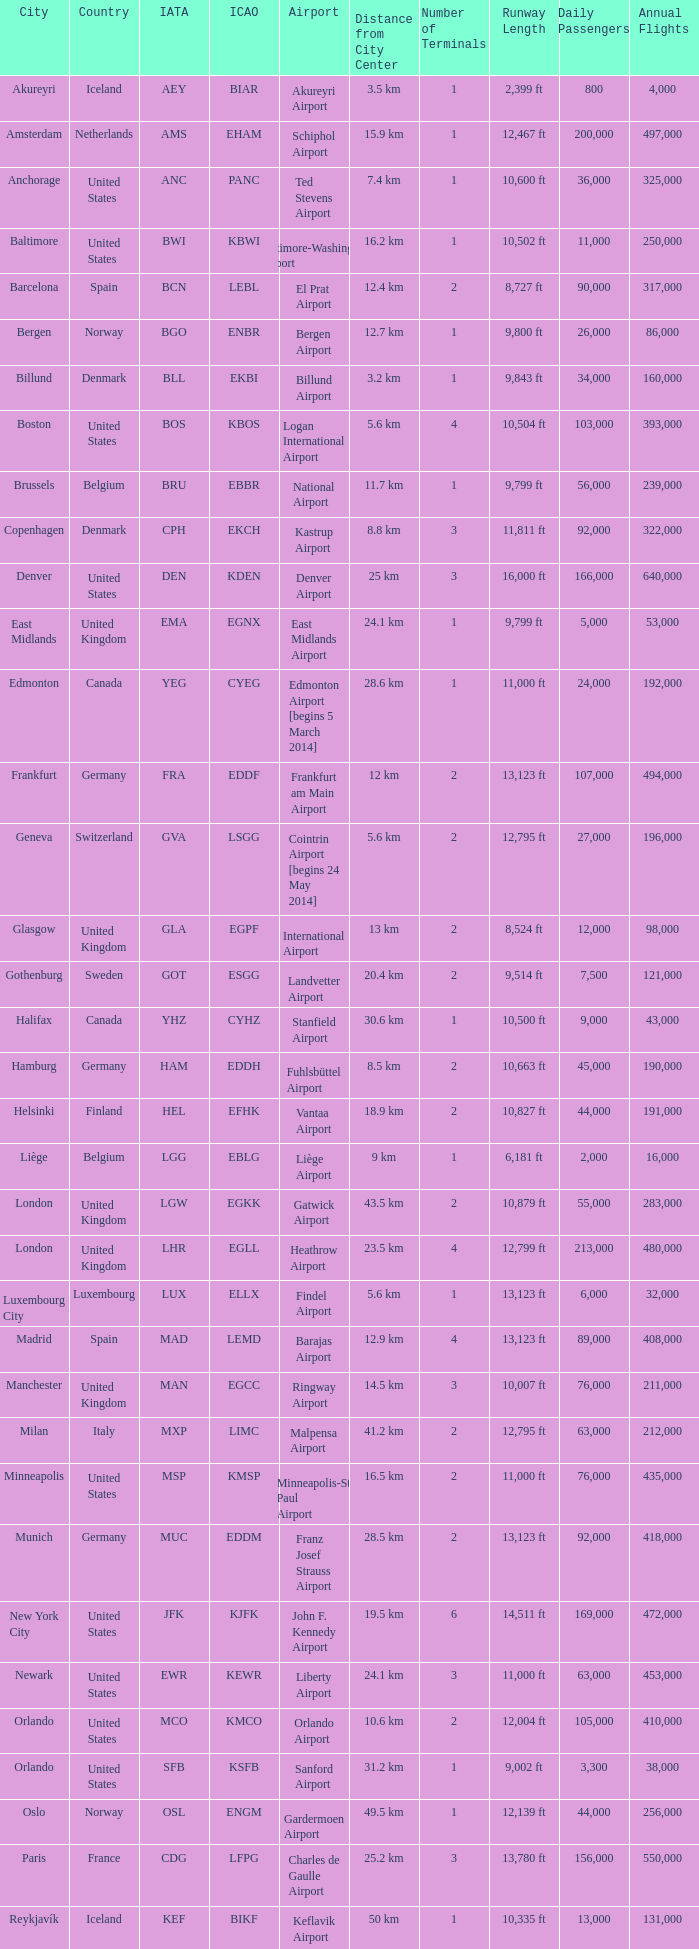Which airport possesses the icao identifier ksea? Seattle–Tacoma Airport. 